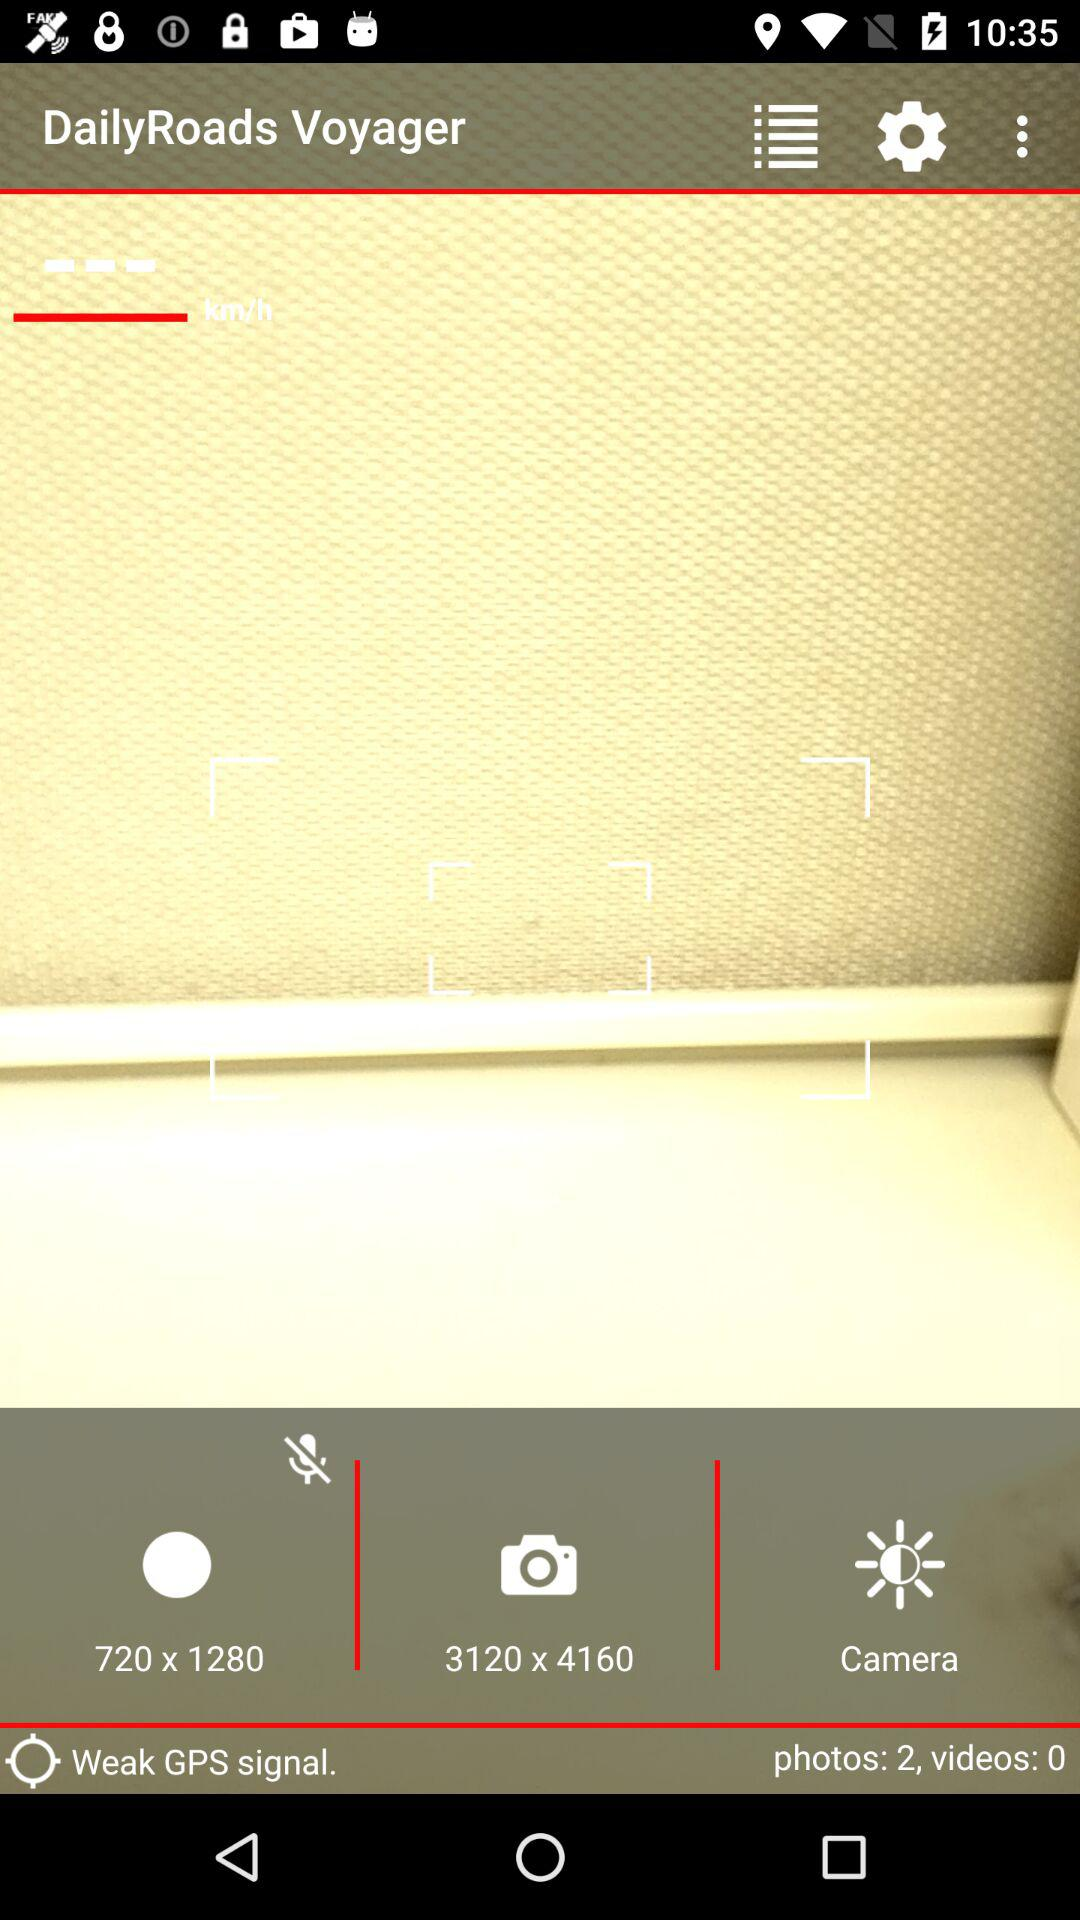What is the application name? The application name is "DailyRoads Voyager". 